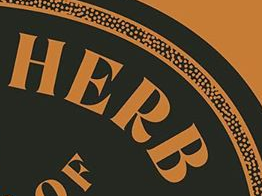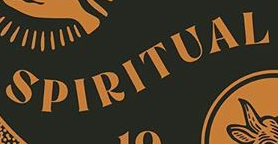What words are shown in these images in order, separated by a semicolon? HERB; SPIRITUAL 